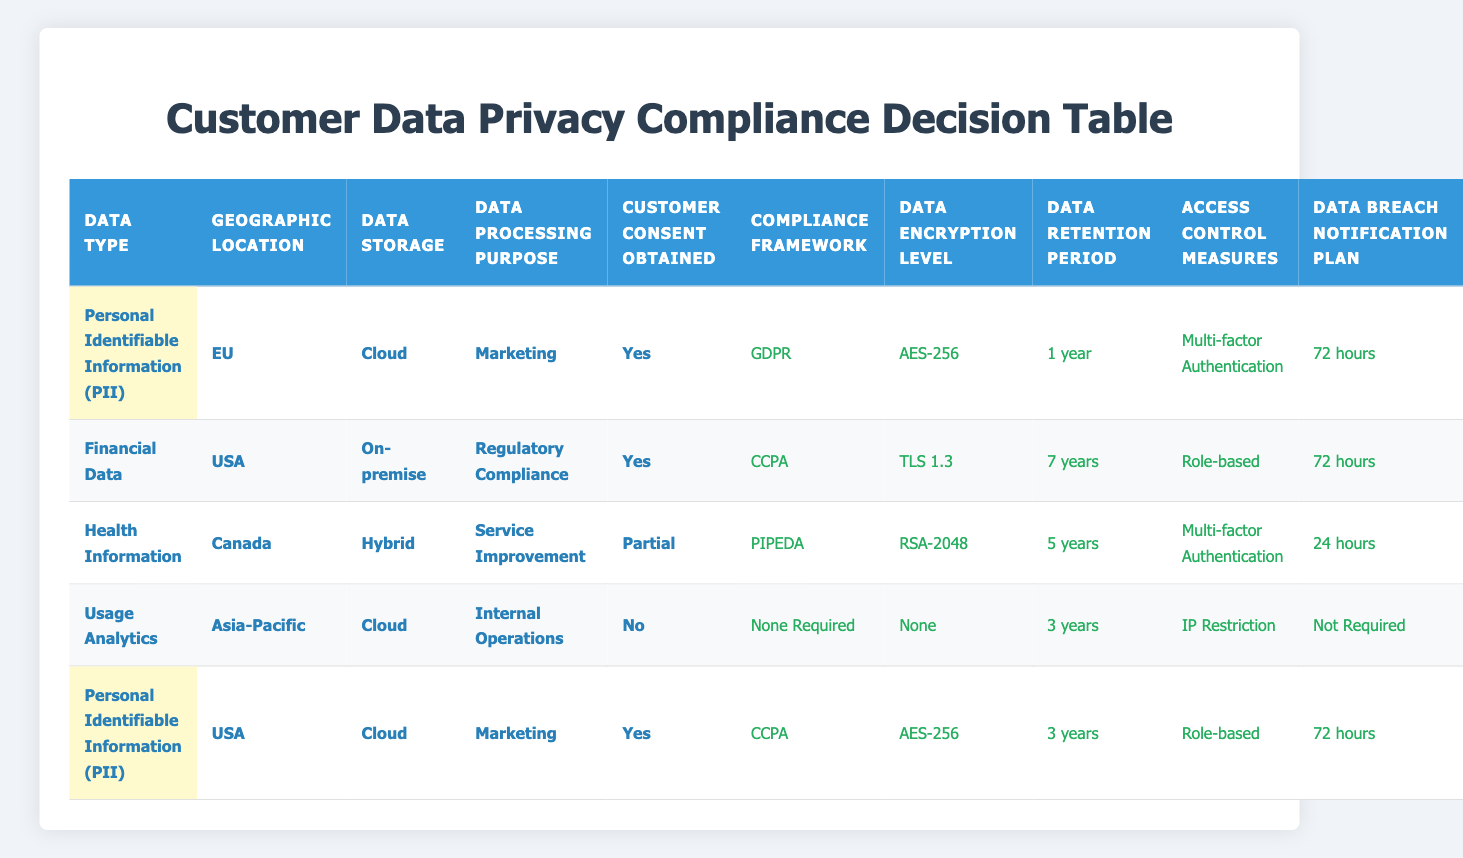What compliance framework applies if data type is health information and customer consent is partial? The data shows that for health information in Canada with partial consent, the compliance framework is PIPEDA based on the rules provided in the table.
Answer: PIPEDA Which data retention period is associated with financial data stored on-premise for regulatory compliance with customer consent obtained? The rule indicates that financial data stored on-premise for regulatory compliance with customer consent obtained has a retention period of 7 years.
Answer: 7 years Is encryption required for usage analytics stored in the cloud with no customer consent? According to the table, for usage analytics in Asia-Pacific that is stored in the cloud without customer consent, no encryption is required.
Answer: No How many different actions are listed for personal identifiable information (PII) in the USA when customer consent is obtained? There are two actions associated with PII in the USA with consent obtained, which are CCPA compliance and AES-256 encryption, indicated across two rows.
Answer: 2 What is the average data retention period for the actions listed in the table? The data retention periods in the table are 1 year, 7 years, 5 years, 3 years, and 3 years. Summing these gives 1 + 7 + 5 + 3 + 3 = 19 years. Then dividing by the number of data points (5) gives 19/5 = 3.8 years.
Answer: 3.8 years How does the data breach notification plan differ between health information and usage analytics? For health information with partial consent, the notification time is 24 hours, while for usage analytics with no consent, the notification plan is not required, showing a significant difference in urgency and requirement.
Answer: 24 hours vs Not Required Can financial data stored in the USA ever have a data breach notification plan requiring more than 72 hours? Referring to the table, financial data in the USA for regulatory compliance with consent has a notification plan of 72 hours, which means it does not require more than 72 hours.
Answer: No What is the access control measure for personal identifiable information (PII) stored in the cloud for marketing in the EU with customer consent? The rule specified for PII in the EU stored in the cloud for marketing with consent states that the access control measure is multi-factor authentication.
Answer: Multi-factor Authentication How many compliance frameworks can be associated with personal identifiable information (PII) across different geographic locations? There are two instances where PII is tied to compliance frameworks: GDPR in the EU and CCPA in the USA, meaning there are two frameworks noted for different locations.
Answer: 2 